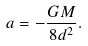<formula> <loc_0><loc_0><loc_500><loc_500>a = - \frac { G M } { 8 d ^ { 2 } } .</formula> 